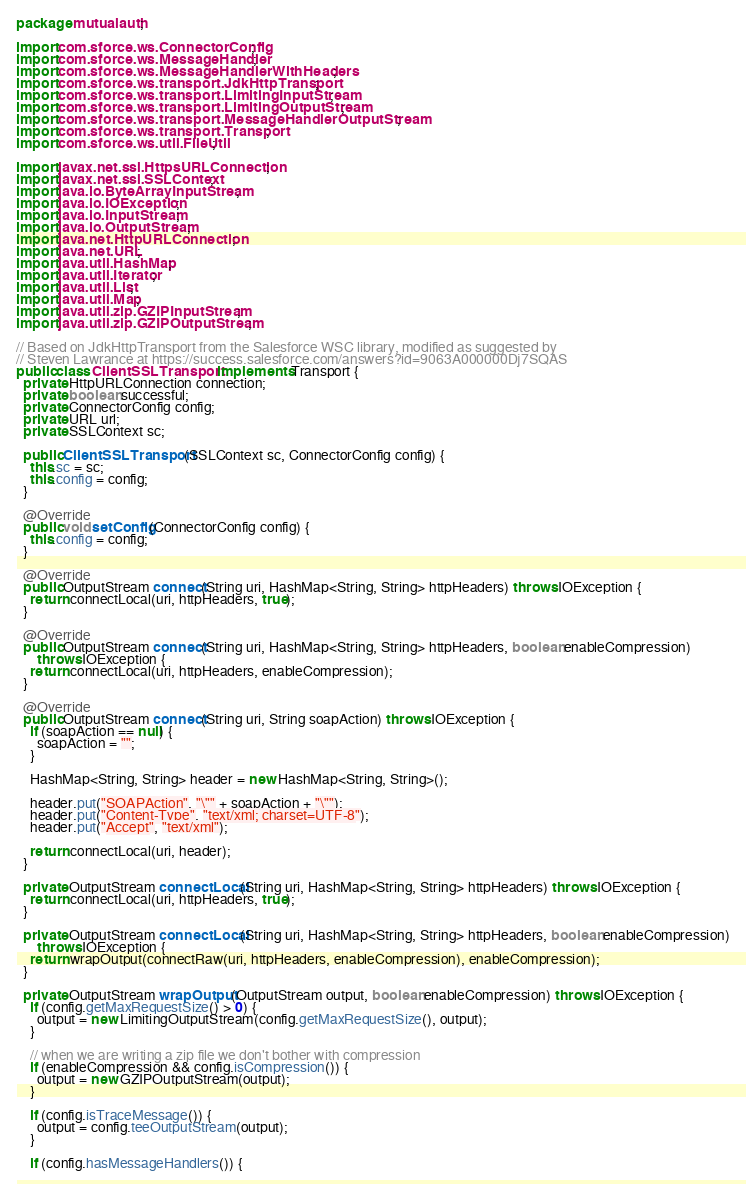Convert code to text. <code><loc_0><loc_0><loc_500><loc_500><_Java_>package mutualauth;

import com.sforce.ws.ConnectorConfig;
import com.sforce.ws.MessageHandler;
import com.sforce.ws.MessageHandlerWithHeaders;
import com.sforce.ws.transport.JdkHttpTransport;
import com.sforce.ws.transport.LimitingInputStream;
import com.sforce.ws.transport.LimitingOutputStream;
import com.sforce.ws.transport.MessageHandlerOutputStream;
import com.sforce.ws.transport.Transport;
import com.sforce.ws.util.FileUtil;

import javax.net.ssl.HttpsURLConnection;
import javax.net.ssl.SSLContext;
import java.io.ByteArrayInputStream;
import java.io.IOException;
import java.io.InputStream;
import java.io.OutputStream;
import java.net.HttpURLConnection;
import java.net.URL;
import java.util.HashMap;
import java.util.Iterator;
import java.util.List;
import java.util.Map;
import java.util.zip.GZIPInputStream;
import java.util.zip.GZIPOutputStream;

// Based on JdkHttpTransport from the Salesforce WSC library, modified as suggested by
// Steven Lawrance at https://success.salesforce.com/answers?id=9063A000000Dj7SQAS
public class ClientSSLTransport implements Transport {
  private HttpURLConnection connection;
  private boolean successful;
  private ConnectorConfig config;
  private URL url;
  private SSLContext sc;

  public ClientSSLTransport(SSLContext sc, ConnectorConfig config) {
    this.sc = sc;
    this.config = config;
  }

  @Override
  public void setConfig(ConnectorConfig config) {
    this.config = config;
  }

  @Override
  public OutputStream connect(String uri, HashMap<String, String> httpHeaders) throws IOException {
    return connectLocal(uri, httpHeaders, true);
  }

  @Override
  public OutputStream connect(String uri, HashMap<String, String> httpHeaders, boolean enableCompression)
      throws IOException {
    return connectLocal(uri, httpHeaders, enableCompression);
  }

  @Override
  public OutputStream connect(String uri, String soapAction) throws IOException {
    if (soapAction == null) {
      soapAction = "";
    }

    HashMap<String, String> header = new HashMap<String, String>();

    header.put("SOAPAction", "\"" + soapAction + "\"");
    header.put("Content-Type", "text/xml; charset=UTF-8");
    header.put("Accept", "text/xml");

    return connectLocal(uri, header);
  }

  private OutputStream connectLocal(String uri, HashMap<String, String> httpHeaders) throws IOException {
    return connectLocal(uri, httpHeaders, true);
  }

  private OutputStream connectLocal(String uri, HashMap<String, String> httpHeaders, boolean enableCompression)
      throws IOException {
    return wrapOutput(connectRaw(uri, httpHeaders, enableCompression), enableCompression);
  }

  private OutputStream wrapOutput(OutputStream output, boolean enableCompression) throws IOException {
    if (config.getMaxRequestSize() > 0) {
      output = new LimitingOutputStream(config.getMaxRequestSize(), output);
    }

    // when we are writing a zip file we don't bother with compression
    if (enableCompression && config.isCompression()) {
      output = new GZIPOutputStream(output);
    }

    if (config.isTraceMessage()) {
      output = config.teeOutputStream(output);
    }

    if (config.hasMessageHandlers()) {</code> 